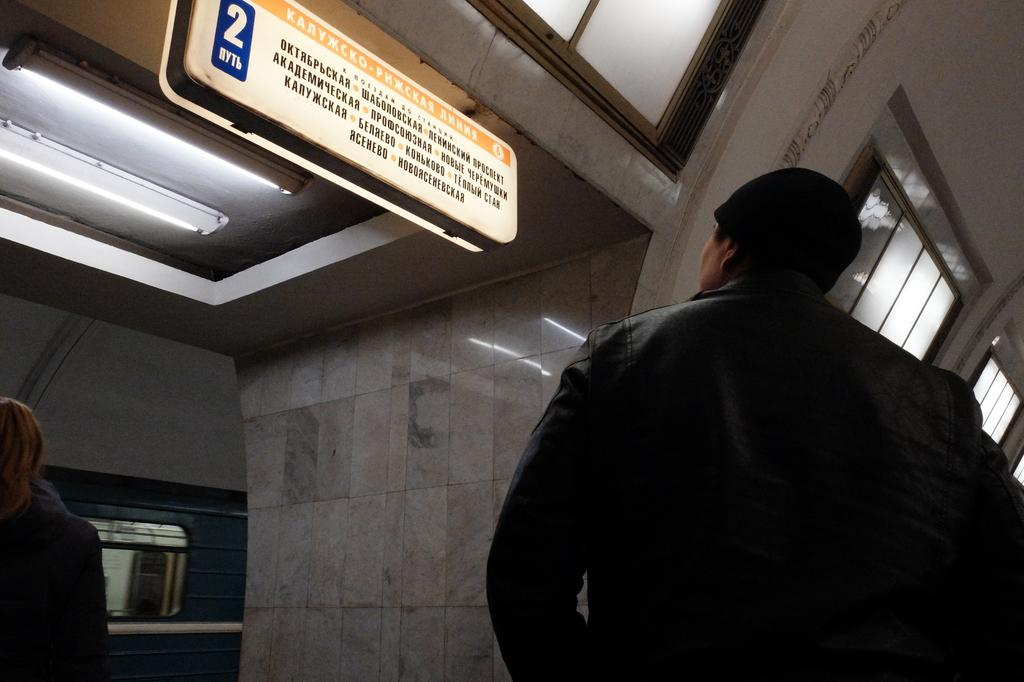How many people are in the image? There are two persons in the image. What is attached to the roof and the wall in the image? There is a board attached to the roof and the wall. Can you describe any openings in the image? A window is visible in the image. Where is the light located in the image? A light is visible on the left side of the image. What is the weight of the persons in the image? The weight of the persons in the image cannot be determined from the image itself. Are the persons in the image engaged in a fight? There is no indication in the image that the persons are engaged in a fight. 